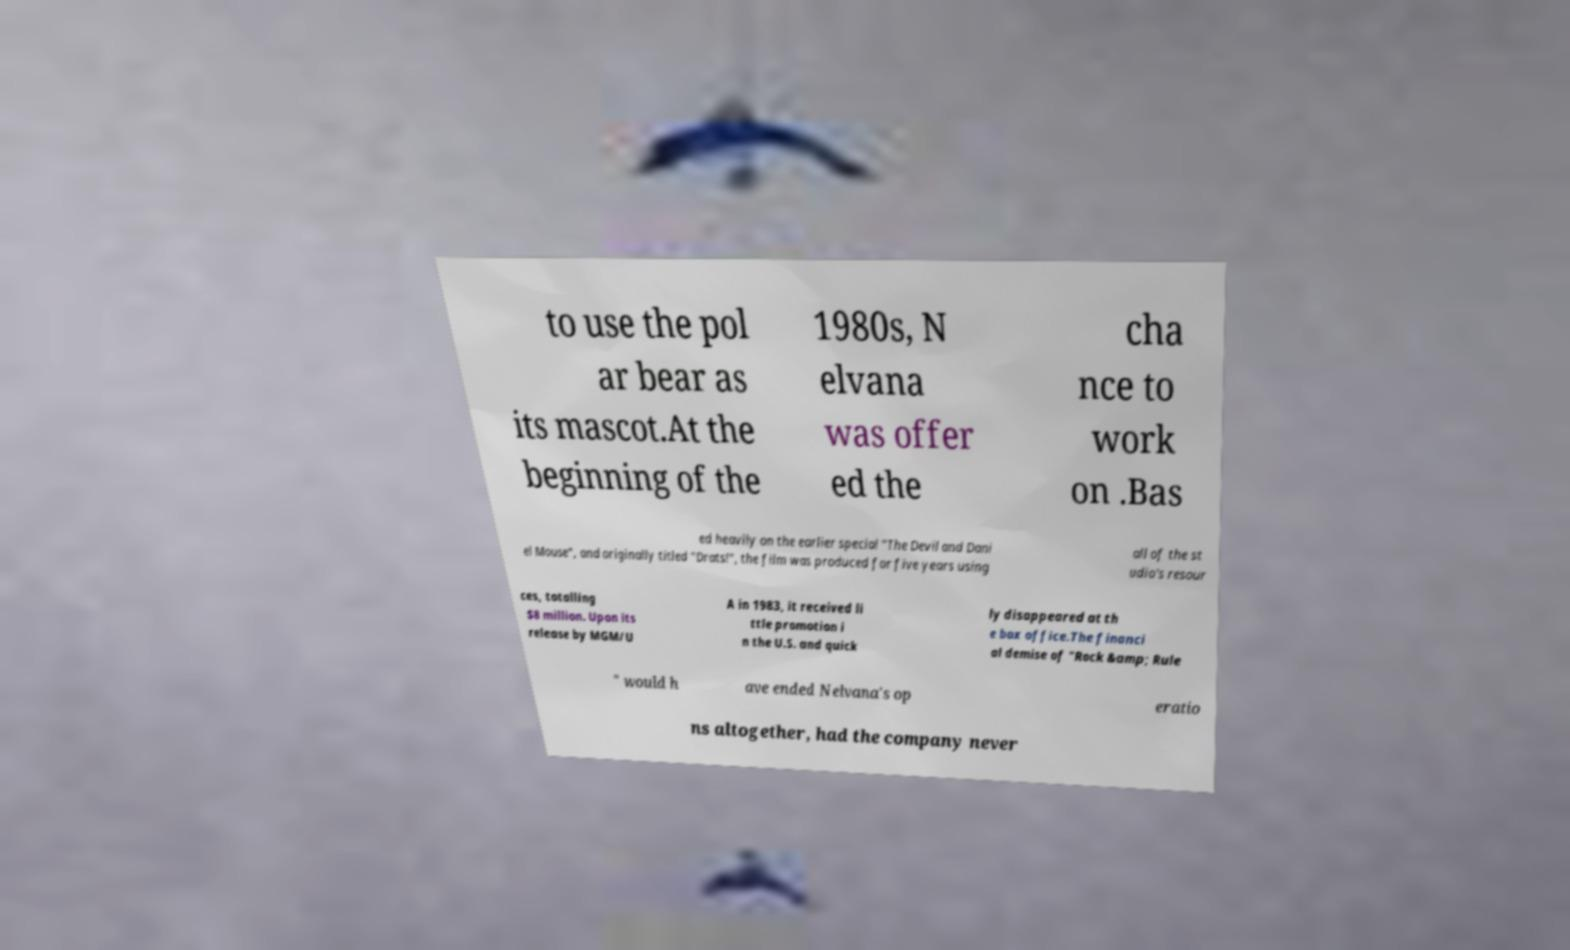There's text embedded in this image that I need extracted. Can you transcribe it verbatim? to use the pol ar bear as its mascot.At the beginning of the 1980s, N elvana was offer ed the cha nce to work on .Bas ed heavily on the earlier special "The Devil and Dani el Mouse", and originally titled "Drats!", the film was produced for five years using all of the st udio's resour ces, totalling $8 million. Upon its release by MGM/U A in 1983, it received li ttle promotion i n the U.S. and quick ly disappeared at th e box office.The financi al demise of "Rock &amp; Rule " would h ave ended Nelvana's op eratio ns altogether, had the company never 